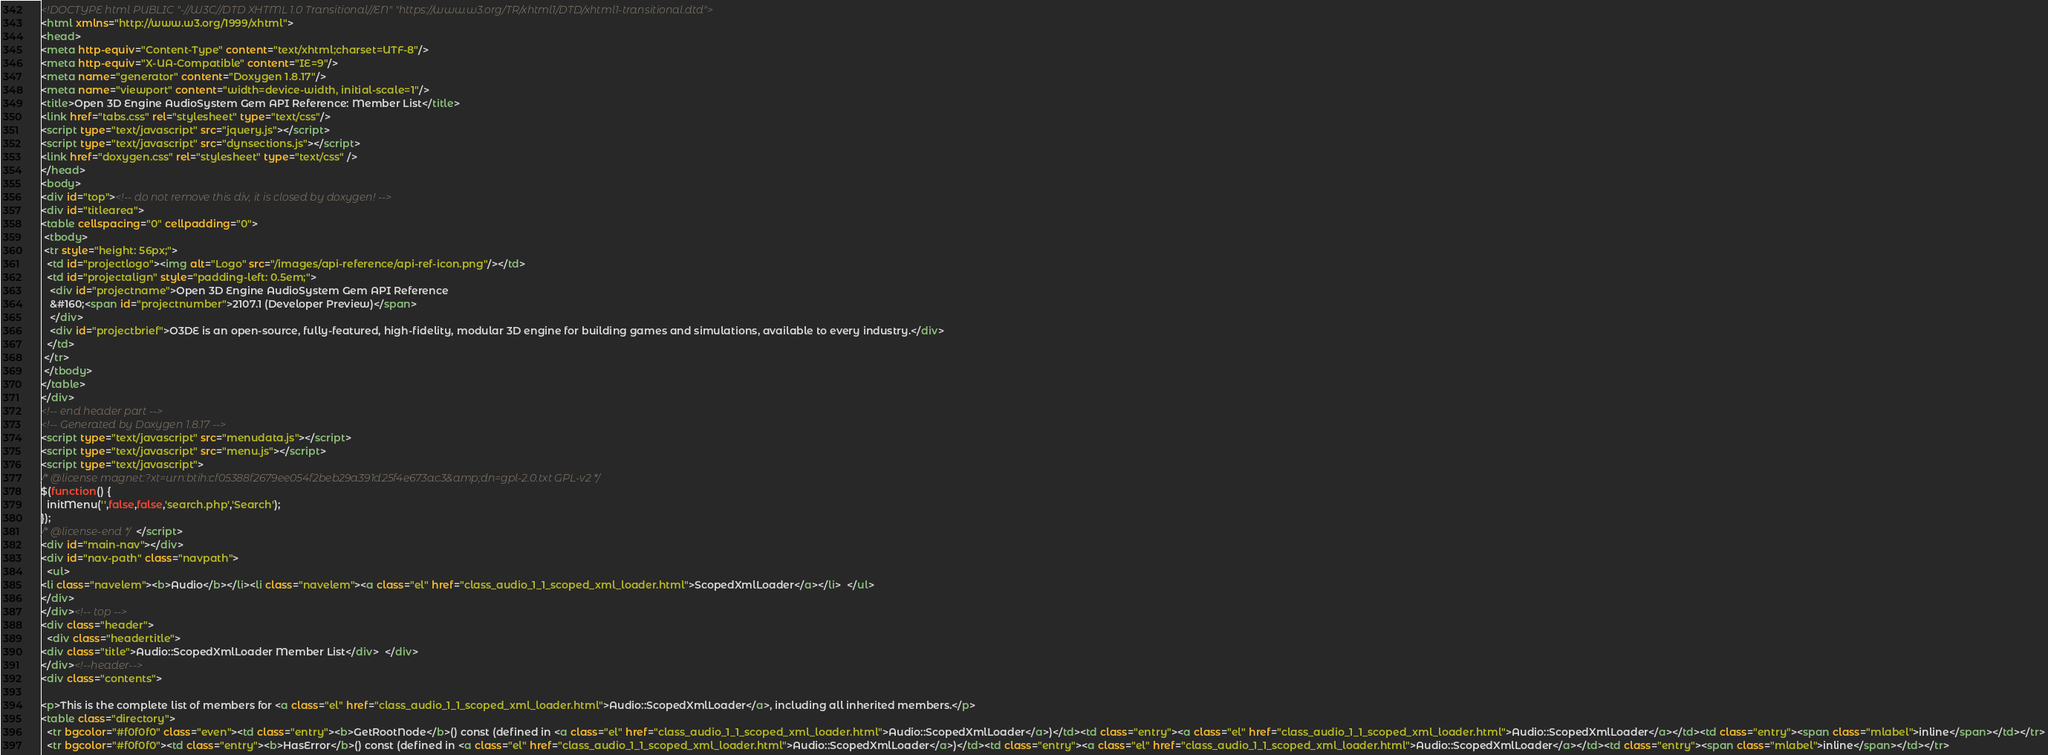Convert code to text. <code><loc_0><loc_0><loc_500><loc_500><_HTML_><!DOCTYPE html PUBLIC "-//W3C//DTD XHTML 1.0 Transitional//EN" "https://www.w3.org/TR/xhtml1/DTD/xhtml1-transitional.dtd">
<html xmlns="http://www.w3.org/1999/xhtml">
<head>
<meta http-equiv="Content-Type" content="text/xhtml;charset=UTF-8"/>
<meta http-equiv="X-UA-Compatible" content="IE=9"/>
<meta name="generator" content="Doxygen 1.8.17"/>
<meta name="viewport" content="width=device-width, initial-scale=1"/>
<title>Open 3D Engine AudioSystem Gem API Reference: Member List</title>
<link href="tabs.css" rel="stylesheet" type="text/css"/>
<script type="text/javascript" src="jquery.js"></script>
<script type="text/javascript" src="dynsections.js"></script>
<link href="doxygen.css" rel="stylesheet" type="text/css" />
</head>
<body>
<div id="top"><!-- do not remove this div, it is closed by doxygen! -->
<div id="titlearea">
<table cellspacing="0" cellpadding="0">
 <tbody>
 <tr style="height: 56px;">
  <td id="projectlogo"><img alt="Logo" src="/images/api-reference/api-ref-icon.png"/></td>
  <td id="projectalign" style="padding-left: 0.5em;">
   <div id="projectname">Open 3D Engine AudioSystem Gem API Reference
   &#160;<span id="projectnumber">2107.1 (Developer Preview)</span>
   </div>
   <div id="projectbrief">O3DE is an open-source, fully-featured, high-fidelity, modular 3D engine for building games and simulations, available to every industry.</div>
  </td>
 </tr>
 </tbody>
</table>
</div>
<!-- end header part -->
<!-- Generated by Doxygen 1.8.17 -->
<script type="text/javascript" src="menudata.js"></script>
<script type="text/javascript" src="menu.js"></script>
<script type="text/javascript">
/* @license magnet:?xt=urn:btih:cf05388f2679ee054f2beb29a391d25f4e673ac3&amp;dn=gpl-2.0.txt GPL-v2 */
$(function() {
  initMenu('',false,false,'search.php','Search');
});
/* @license-end */</script>
<div id="main-nav"></div>
<div id="nav-path" class="navpath">
  <ul>
<li class="navelem"><b>Audio</b></li><li class="navelem"><a class="el" href="class_audio_1_1_scoped_xml_loader.html">ScopedXmlLoader</a></li>  </ul>
</div>
</div><!-- top -->
<div class="header">
  <div class="headertitle">
<div class="title">Audio::ScopedXmlLoader Member List</div>  </div>
</div><!--header-->
<div class="contents">

<p>This is the complete list of members for <a class="el" href="class_audio_1_1_scoped_xml_loader.html">Audio::ScopedXmlLoader</a>, including all inherited members.</p>
<table class="directory">
  <tr bgcolor="#f0f0f0" class="even"><td class="entry"><b>GetRootNode</b>() const (defined in <a class="el" href="class_audio_1_1_scoped_xml_loader.html">Audio::ScopedXmlLoader</a>)</td><td class="entry"><a class="el" href="class_audio_1_1_scoped_xml_loader.html">Audio::ScopedXmlLoader</a></td><td class="entry"><span class="mlabel">inline</span></td></tr>
  <tr bgcolor="#f0f0f0"><td class="entry"><b>HasError</b>() const (defined in <a class="el" href="class_audio_1_1_scoped_xml_loader.html">Audio::ScopedXmlLoader</a>)</td><td class="entry"><a class="el" href="class_audio_1_1_scoped_xml_loader.html">Audio::ScopedXmlLoader</a></td><td class="entry"><span class="mlabel">inline</span></td></tr></code> 